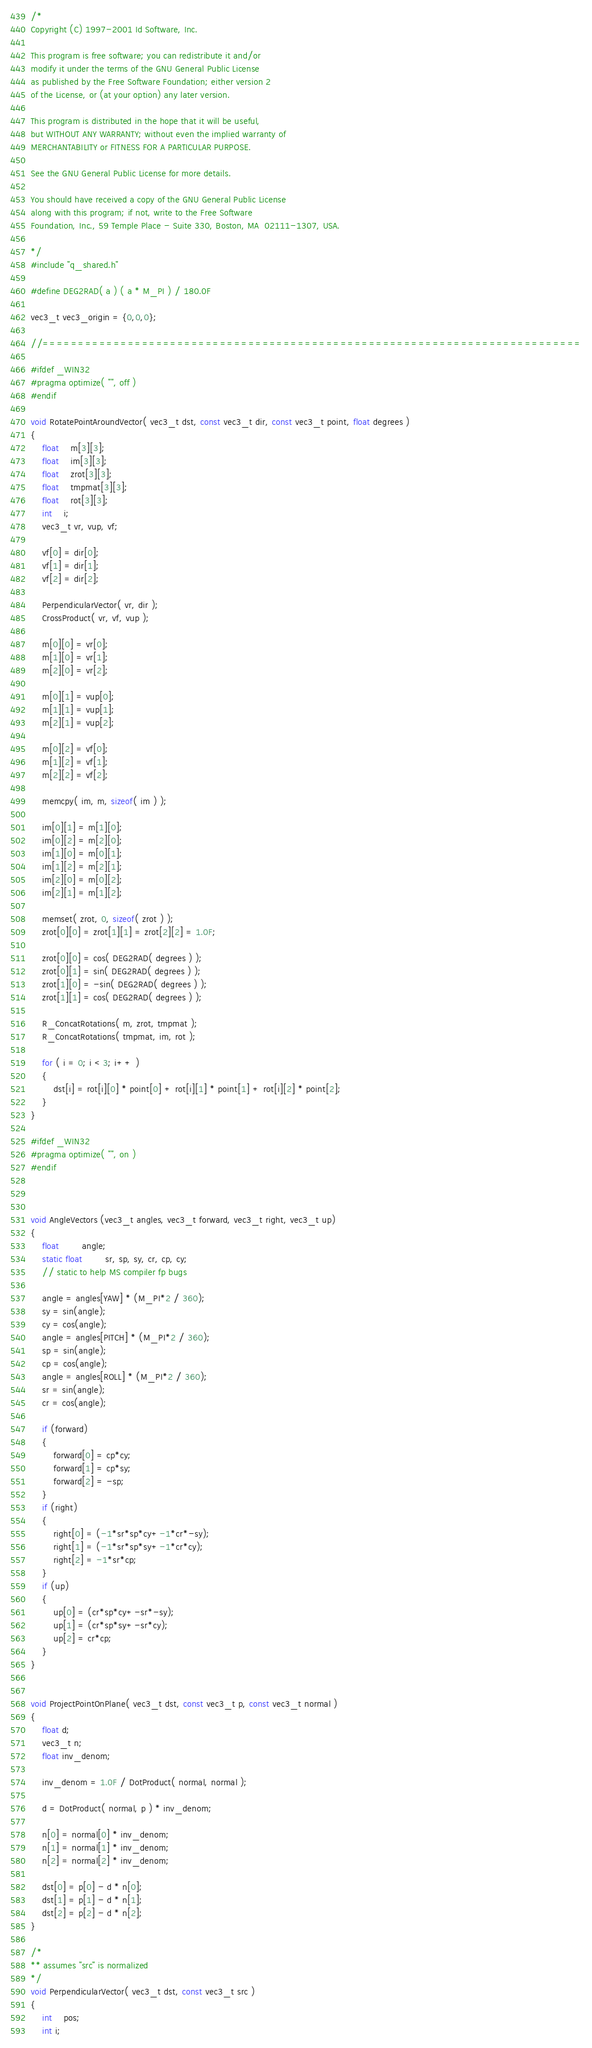Convert code to text. <code><loc_0><loc_0><loc_500><loc_500><_C_>/*
Copyright (C) 1997-2001 Id Software, Inc.

This program is free software; you can redistribute it and/or
modify it under the terms of the GNU General Public License
as published by the Free Software Foundation; either version 2
of the License, or (at your option) any later version.

This program is distributed in the hope that it will be useful,
but WITHOUT ANY WARRANTY; without even the implied warranty of
MERCHANTABILITY or FITNESS FOR A PARTICULAR PURPOSE.  

See the GNU General Public License for more details.

You should have received a copy of the GNU General Public License
along with this program; if not, write to the Free Software
Foundation, Inc., 59 Temple Place - Suite 330, Boston, MA  02111-1307, USA.

*/
#include "q_shared.h"

#define DEG2RAD( a ) ( a * M_PI ) / 180.0F

vec3_t vec3_origin = {0,0,0};

//============================================================================

#ifdef _WIN32
#pragma optimize( "", off )
#endif

void RotatePointAroundVector( vec3_t dst, const vec3_t dir, const vec3_t point, float degrees )
{
	float	m[3][3];
	float	im[3][3];
	float	zrot[3][3];
	float	tmpmat[3][3];
	float	rot[3][3];
	int	i;
	vec3_t vr, vup, vf;

	vf[0] = dir[0];
	vf[1] = dir[1];
	vf[2] = dir[2];

	PerpendicularVector( vr, dir );
	CrossProduct( vr, vf, vup );

	m[0][0] = vr[0];
	m[1][0] = vr[1];
	m[2][0] = vr[2];

	m[0][1] = vup[0];
	m[1][1] = vup[1];
	m[2][1] = vup[2];

	m[0][2] = vf[0];
	m[1][2] = vf[1];
	m[2][2] = vf[2];

	memcpy( im, m, sizeof( im ) );

	im[0][1] = m[1][0];
	im[0][2] = m[2][0];
	im[1][0] = m[0][1];
	im[1][2] = m[2][1];
	im[2][0] = m[0][2];
	im[2][1] = m[1][2];

	memset( zrot, 0, sizeof( zrot ) );
	zrot[0][0] = zrot[1][1] = zrot[2][2] = 1.0F;

	zrot[0][0] = cos( DEG2RAD( degrees ) );
	zrot[0][1] = sin( DEG2RAD( degrees ) );
	zrot[1][0] = -sin( DEG2RAD( degrees ) );
	zrot[1][1] = cos( DEG2RAD( degrees ) );

	R_ConcatRotations( m, zrot, tmpmat );
	R_ConcatRotations( tmpmat, im, rot );

	for ( i = 0; i < 3; i++ )
	{
		dst[i] = rot[i][0] * point[0] + rot[i][1] * point[1] + rot[i][2] * point[2];
	}
}

#ifdef _WIN32
#pragma optimize( "", on )
#endif



void AngleVectors (vec3_t angles, vec3_t forward, vec3_t right, vec3_t up)
{
	float		angle;
	static float		sr, sp, sy, cr, cp, cy;
	// static to help MS compiler fp bugs

	angle = angles[YAW] * (M_PI*2 / 360);
	sy = sin(angle);
	cy = cos(angle);
	angle = angles[PITCH] * (M_PI*2 / 360);
	sp = sin(angle);
	cp = cos(angle);
	angle = angles[ROLL] * (M_PI*2 / 360);
	sr = sin(angle);
	cr = cos(angle);

	if (forward)
	{
		forward[0] = cp*cy;
		forward[1] = cp*sy;
		forward[2] = -sp;
	}
	if (right)
	{
		right[0] = (-1*sr*sp*cy+-1*cr*-sy);
		right[1] = (-1*sr*sp*sy+-1*cr*cy);
		right[2] = -1*sr*cp;
	}
	if (up)
	{
		up[0] = (cr*sp*cy+-sr*-sy);
		up[1] = (cr*sp*sy+-sr*cy);
		up[2] = cr*cp;
	}
}


void ProjectPointOnPlane( vec3_t dst, const vec3_t p, const vec3_t normal )
{
	float d;
	vec3_t n;
	float inv_denom;

	inv_denom = 1.0F / DotProduct( normal, normal );

	d = DotProduct( normal, p ) * inv_denom;

	n[0] = normal[0] * inv_denom;
	n[1] = normal[1] * inv_denom;
	n[2] = normal[2] * inv_denom;

	dst[0] = p[0] - d * n[0];
	dst[1] = p[1] - d * n[1];
	dst[2] = p[2] - d * n[2];
}

/*
** assumes "src" is normalized
*/
void PerpendicularVector( vec3_t dst, const vec3_t src )
{
	int	pos;
	int i;</code> 